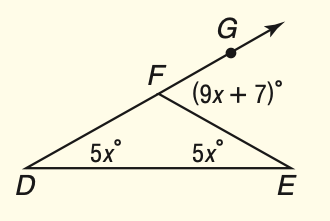Answer the mathemtical geometry problem and directly provide the correct option letter.
Question: What is m \angle E F G?
Choices: A: 35 B: 70 C: 90 D: 110 B 